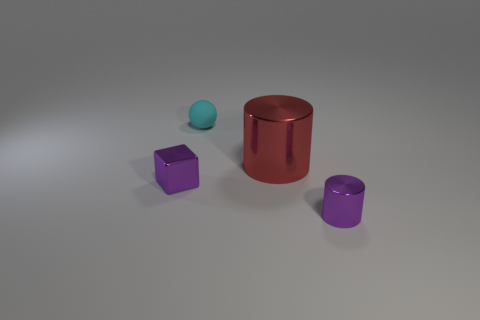Add 2 purple metallic cubes. How many objects exist? 6 Subtract all spheres. How many objects are left? 3 Subtract all tiny cyan metal cubes. Subtract all large cylinders. How many objects are left? 3 Add 4 small purple metallic things. How many small purple metallic things are left? 6 Add 1 blocks. How many blocks exist? 2 Subtract 1 red cylinders. How many objects are left? 3 